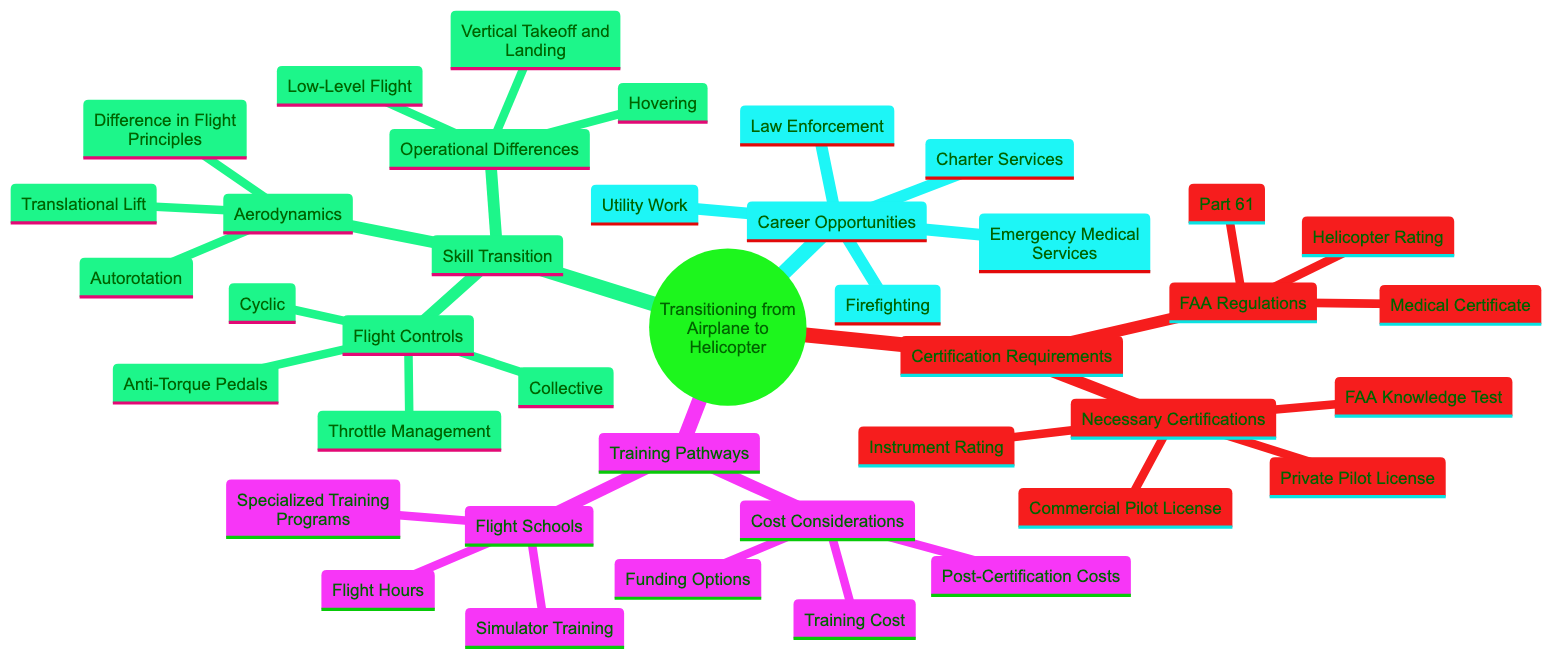What are the two main categories under Certification Requirements? The diagram shows two primary categories: 'FAA Regulations' and 'Necessary Certifications' under the 'Certification Requirements' node.
Answer: FAA Regulations, Necessary Certifications What is required for adding a helicopter rating? The diagram explicitly states that you need to obtain a 'Helicopter Rating', which refers to adding a Rotorcraft-Helicopter Category and Class Rating.
Answer: Helicopter Rating What training pathway involves utilizing helicopter simulators? The 'Training Pathways' section specifies that 'Simulator Training' refers to utilizing helicopter simulators for practicing maneuvers.
Answer: Simulator Training How many types of pilot licenses are listed under Necessary Certifications? There are four types of pilot licenses mentioned: Private Pilot License, Commercial Pilot License, Instrument Rating, and FAA Knowledge Test.
Answer: Four What is a significant operational difference when transitioning to helicopters? The diagram highlights 'Hovering' as a notable operational difference that pilots must master when transitioning from airplanes to helicopters.
Answer: Hovering Which FAA regulation is associated with pilot and flight instructor certification? Under 'FAA Regulations', the diagram lists 'Part 61', which pertains to the certification of pilots and flight instructors.
Answer: Part 61 What are two examples of career opportunities available for helicopter pilots? The diagram outlines five career opportunities: Emergency Medical Services, Charter Services, Utility Work, Law Enforcement, and Firefighting. Any two from this list can be referenced.
Answer: Emergency Medical Services, Charter Services What kind of training does 'Cost Considerations' include? The 'Cost Considerations' section details expenses related to Ground School and Flight Time, which are critical components of flight training costs.
Answer: Training Cost What does the 'Collective' control change in helicopter flight? The diagram specifies that the 'Collective' changes the pitch of the rotor blades, which is crucial for helicopter control.
Answer: Pitch of the Rotor Blades 